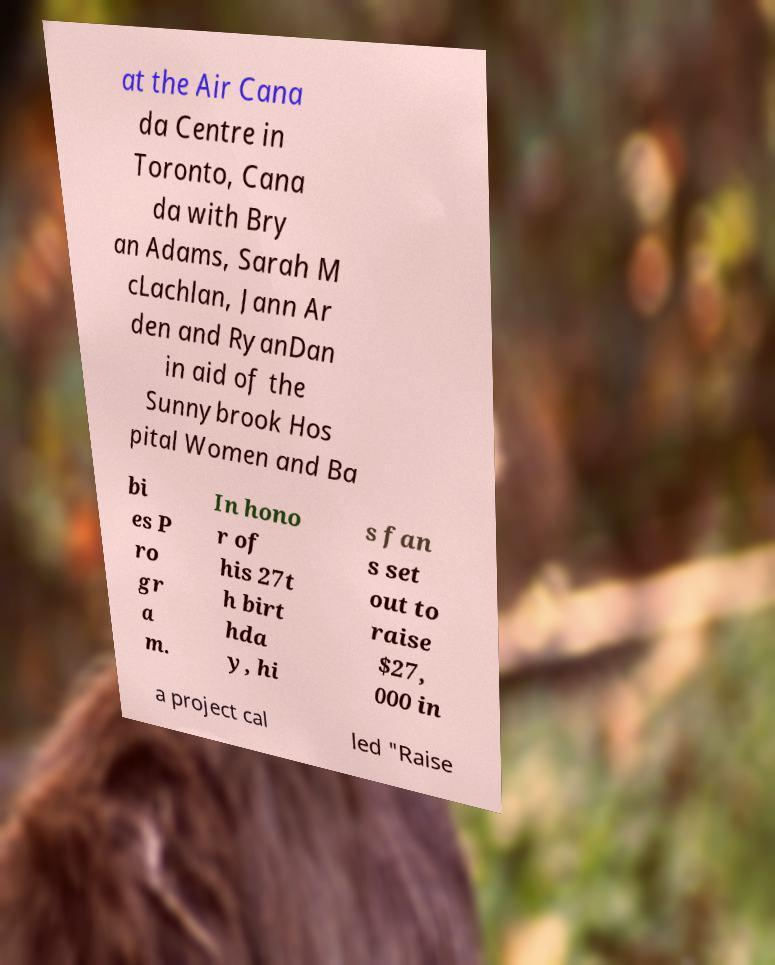Please read and relay the text visible in this image. What does it say? at the Air Cana da Centre in Toronto, Cana da with Bry an Adams, Sarah M cLachlan, Jann Ar den and RyanDan in aid of the Sunnybrook Hos pital Women and Ba bi es P ro gr a m. In hono r of his 27t h birt hda y, hi s fan s set out to raise $27, 000 in a project cal led "Raise 